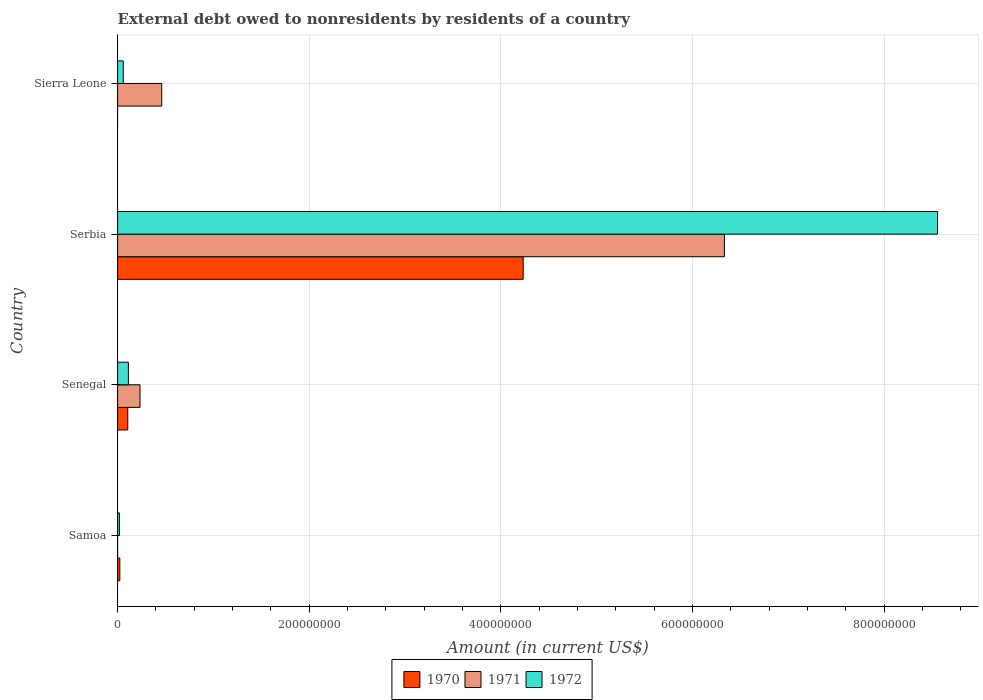How many groups of bars are there?
Your answer should be compact. 4. Are the number of bars per tick equal to the number of legend labels?
Your answer should be compact. No. How many bars are there on the 3rd tick from the top?
Ensure brevity in your answer.  3. How many bars are there on the 4th tick from the bottom?
Make the answer very short. 2. What is the label of the 3rd group of bars from the top?
Keep it short and to the point. Senegal. What is the external debt owed by residents in 1970 in Samoa?
Offer a terse response. 2.32e+06. Across all countries, what is the maximum external debt owed by residents in 1970?
Provide a succinct answer. 4.23e+08. Across all countries, what is the minimum external debt owed by residents in 1972?
Keep it short and to the point. 1.89e+06. In which country was the external debt owed by residents in 1971 maximum?
Provide a succinct answer. Serbia. What is the total external debt owed by residents in 1972 in the graph?
Ensure brevity in your answer.  8.75e+08. What is the difference between the external debt owed by residents in 1972 in Serbia and that in Sierra Leone?
Provide a short and direct response. 8.50e+08. What is the difference between the external debt owed by residents in 1972 in Sierra Leone and the external debt owed by residents in 1970 in Samoa?
Provide a short and direct response. 3.61e+06. What is the average external debt owed by residents in 1970 per country?
Ensure brevity in your answer.  1.09e+08. What is the difference between the external debt owed by residents in 1972 and external debt owed by residents in 1970 in Serbia?
Your answer should be very brief. 4.32e+08. In how many countries, is the external debt owed by residents in 1971 greater than 600000000 US$?
Make the answer very short. 1. What is the ratio of the external debt owed by residents in 1972 in Senegal to that in Serbia?
Your response must be concise. 0.01. What is the difference between the highest and the second highest external debt owed by residents in 1970?
Offer a very short reply. 4.13e+08. What is the difference between the highest and the lowest external debt owed by residents in 1971?
Provide a short and direct response. 6.33e+08. In how many countries, is the external debt owed by residents in 1970 greater than the average external debt owed by residents in 1970 taken over all countries?
Your answer should be very brief. 1. Are all the bars in the graph horizontal?
Offer a terse response. Yes. Are the values on the major ticks of X-axis written in scientific E-notation?
Make the answer very short. No. Does the graph contain any zero values?
Offer a very short reply. Yes. How many legend labels are there?
Your response must be concise. 3. What is the title of the graph?
Make the answer very short. External debt owed to nonresidents by residents of a country. Does "1982" appear as one of the legend labels in the graph?
Offer a terse response. No. What is the Amount (in current US$) in 1970 in Samoa?
Offer a very short reply. 2.32e+06. What is the Amount (in current US$) in 1972 in Samoa?
Offer a very short reply. 1.89e+06. What is the Amount (in current US$) of 1970 in Senegal?
Offer a terse response. 1.06e+07. What is the Amount (in current US$) of 1971 in Senegal?
Your response must be concise. 2.34e+07. What is the Amount (in current US$) in 1972 in Senegal?
Your answer should be compact. 1.12e+07. What is the Amount (in current US$) in 1970 in Serbia?
Your answer should be compact. 4.23e+08. What is the Amount (in current US$) of 1971 in Serbia?
Your answer should be very brief. 6.33e+08. What is the Amount (in current US$) of 1972 in Serbia?
Give a very brief answer. 8.56e+08. What is the Amount (in current US$) in 1971 in Sierra Leone?
Provide a short and direct response. 4.61e+07. What is the Amount (in current US$) of 1972 in Sierra Leone?
Offer a terse response. 5.94e+06. Across all countries, what is the maximum Amount (in current US$) in 1970?
Your answer should be very brief. 4.23e+08. Across all countries, what is the maximum Amount (in current US$) of 1971?
Your answer should be very brief. 6.33e+08. Across all countries, what is the maximum Amount (in current US$) in 1972?
Your answer should be very brief. 8.56e+08. Across all countries, what is the minimum Amount (in current US$) of 1970?
Offer a very short reply. 0. Across all countries, what is the minimum Amount (in current US$) of 1972?
Your response must be concise. 1.89e+06. What is the total Amount (in current US$) of 1970 in the graph?
Keep it short and to the point. 4.36e+08. What is the total Amount (in current US$) of 1971 in the graph?
Make the answer very short. 7.03e+08. What is the total Amount (in current US$) of 1972 in the graph?
Ensure brevity in your answer.  8.75e+08. What is the difference between the Amount (in current US$) in 1970 in Samoa and that in Senegal?
Keep it short and to the point. -8.28e+06. What is the difference between the Amount (in current US$) of 1972 in Samoa and that in Senegal?
Ensure brevity in your answer.  -9.34e+06. What is the difference between the Amount (in current US$) in 1970 in Samoa and that in Serbia?
Offer a very short reply. -4.21e+08. What is the difference between the Amount (in current US$) in 1972 in Samoa and that in Serbia?
Offer a terse response. -8.54e+08. What is the difference between the Amount (in current US$) in 1972 in Samoa and that in Sierra Leone?
Provide a succinct answer. -4.05e+06. What is the difference between the Amount (in current US$) of 1970 in Senegal and that in Serbia?
Offer a terse response. -4.13e+08. What is the difference between the Amount (in current US$) of 1971 in Senegal and that in Serbia?
Ensure brevity in your answer.  -6.10e+08. What is the difference between the Amount (in current US$) in 1972 in Senegal and that in Serbia?
Your answer should be compact. -8.45e+08. What is the difference between the Amount (in current US$) of 1971 in Senegal and that in Sierra Leone?
Provide a succinct answer. -2.27e+07. What is the difference between the Amount (in current US$) of 1972 in Senegal and that in Sierra Leone?
Provide a succinct answer. 5.29e+06. What is the difference between the Amount (in current US$) in 1971 in Serbia and that in Sierra Leone?
Your answer should be very brief. 5.87e+08. What is the difference between the Amount (in current US$) of 1972 in Serbia and that in Sierra Leone?
Make the answer very short. 8.50e+08. What is the difference between the Amount (in current US$) of 1970 in Samoa and the Amount (in current US$) of 1971 in Senegal?
Ensure brevity in your answer.  -2.10e+07. What is the difference between the Amount (in current US$) of 1970 in Samoa and the Amount (in current US$) of 1972 in Senegal?
Offer a very short reply. -8.91e+06. What is the difference between the Amount (in current US$) in 1970 in Samoa and the Amount (in current US$) in 1971 in Serbia?
Offer a terse response. -6.31e+08. What is the difference between the Amount (in current US$) in 1970 in Samoa and the Amount (in current US$) in 1972 in Serbia?
Offer a terse response. -8.54e+08. What is the difference between the Amount (in current US$) of 1970 in Samoa and the Amount (in current US$) of 1971 in Sierra Leone?
Give a very brief answer. -4.37e+07. What is the difference between the Amount (in current US$) of 1970 in Samoa and the Amount (in current US$) of 1972 in Sierra Leone?
Keep it short and to the point. -3.61e+06. What is the difference between the Amount (in current US$) in 1970 in Senegal and the Amount (in current US$) in 1971 in Serbia?
Give a very brief answer. -6.23e+08. What is the difference between the Amount (in current US$) in 1970 in Senegal and the Amount (in current US$) in 1972 in Serbia?
Your answer should be very brief. -8.45e+08. What is the difference between the Amount (in current US$) in 1971 in Senegal and the Amount (in current US$) in 1972 in Serbia?
Your response must be concise. -8.32e+08. What is the difference between the Amount (in current US$) in 1970 in Senegal and the Amount (in current US$) in 1971 in Sierra Leone?
Keep it short and to the point. -3.55e+07. What is the difference between the Amount (in current US$) of 1970 in Senegal and the Amount (in current US$) of 1972 in Sierra Leone?
Give a very brief answer. 4.66e+06. What is the difference between the Amount (in current US$) in 1971 in Senegal and the Amount (in current US$) in 1972 in Sierra Leone?
Offer a very short reply. 1.74e+07. What is the difference between the Amount (in current US$) in 1970 in Serbia and the Amount (in current US$) in 1971 in Sierra Leone?
Make the answer very short. 3.77e+08. What is the difference between the Amount (in current US$) of 1970 in Serbia and the Amount (in current US$) of 1972 in Sierra Leone?
Your answer should be very brief. 4.17e+08. What is the difference between the Amount (in current US$) of 1971 in Serbia and the Amount (in current US$) of 1972 in Sierra Leone?
Ensure brevity in your answer.  6.28e+08. What is the average Amount (in current US$) of 1970 per country?
Make the answer very short. 1.09e+08. What is the average Amount (in current US$) in 1971 per country?
Keep it short and to the point. 1.76e+08. What is the average Amount (in current US$) in 1972 per country?
Offer a terse response. 2.19e+08. What is the difference between the Amount (in current US$) in 1970 and Amount (in current US$) in 1972 in Samoa?
Give a very brief answer. 4.36e+05. What is the difference between the Amount (in current US$) of 1970 and Amount (in current US$) of 1971 in Senegal?
Offer a very short reply. -1.28e+07. What is the difference between the Amount (in current US$) in 1970 and Amount (in current US$) in 1972 in Senegal?
Offer a very short reply. -6.30e+05. What is the difference between the Amount (in current US$) of 1971 and Amount (in current US$) of 1972 in Senegal?
Offer a very short reply. 1.21e+07. What is the difference between the Amount (in current US$) in 1970 and Amount (in current US$) in 1971 in Serbia?
Give a very brief answer. -2.10e+08. What is the difference between the Amount (in current US$) in 1970 and Amount (in current US$) in 1972 in Serbia?
Provide a short and direct response. -4.32e+08. What is the difference between the Amount (in current US$) of 1971 and Amount (in current US$) of 1972 in Serbia?
Give a very brief answer. -2.22e+08. What is the difference between the Amount (in current US$) in 1971 and Amount (in current US$) in 1972 in Sierra Leone?
Give a very brief answer. 4.01e+07. What is the ratio of the Amount (in current US$) in 1970 in Samoa to that in Senegal?
Provide a succinct answer. 0.22. What is the ratio of the Amount (in current US$) in 1972 in Samoa to that in Senegal?
Offer a very short reply. 0.17. What is the ratio of the Amount (in current US$) of 1970 in Samoa to that in Serbia?
Your response must be concise. 0.01. What is the ratio of the Amount (in current US$) of 1972 in Samoa to that in Serbia?
Your answer should be compact. 0. What is the ratio of the Amount (in current US$) of 1972 in Samoa to that in Sierra Leone?
Your answer should be compact. 0.32. What is the ratio of the Amount (in current US$) in 1970 in Senegal to that in Serbia?
Give a very brief answer. 0.03. What is the ratio of the Amount (in current US$) of 1971 in Senegal to that in Serbia?
Your response must be concise. 0.04. What is the ratio of the Amount (in current US$) of 1972 in Senegal to that in Serbia?
Provide a succinct answer. 0.01. What is the ratio of the Amount (in current US$) in 1971 in Senegal to that in Sierra Leone?
Your answer should be compact. 0.51. What is the ratio of the Amount (in current US$) in 1972 in Senegal to that in Sierra Leone?
Keep it short and to the point. 1.89. What is the ratio of the Amount (in current US$) of 1971 in Serbia to that in Sierra Leone?
Offer a very short reply. 13.75. What is the ratio of the Amount (in current US$) in 1972 in Serbia to that in Sierra Leone?
Ensure brevity in your answer.  144.15. What is the difference between the highest and the second highest Amount (in current US$) of 1970?
Ensure brevity in your answer.  4.13e+08. What is the difference between the highest and the second highest Amount (in current US$) in 1971?
Ensure brevity in your answer.  5.87e+08. What is the difference between the highest and the second highest Amount (in current US$) of 1972?
Provide a succinct answer. 8.45e+08. What is the difference between the highest and the lowest Amount (in current US$) in 1970?
Give a very brief answer. 4.23e+08. What is the difference between the highest and the lowest Amount (in current US$) in 1971?
Keep it short and to the point. 6.33e+08. What is the difference between the highest and the lowest Amount (in current US$) of 1972?
Offer a very short reply. 8.54e+08. 